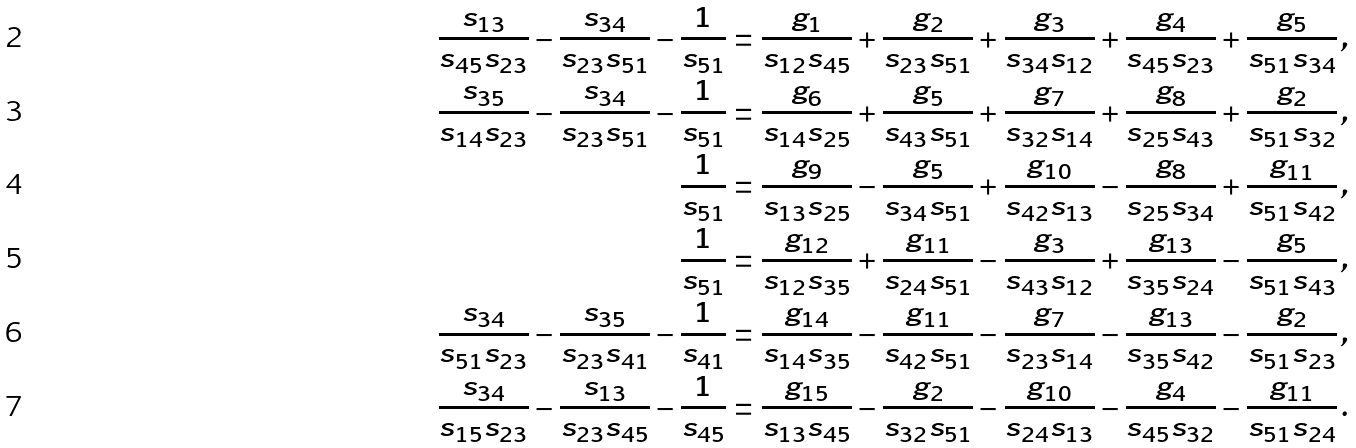<formula> <loc_0><loc_0><loc_500><loc_500>\frac { s _ { 1 3 } } { s _ { 4 5 } s _ { 2 3 } } - \frac { s _ { 3 4 } } { s _ { 2 3 } s _ { 5 1 } } - \frac { 1 } { s _ { 5 1 } } & = \frac { g _ { 1 } } { s _ { 1 2 } s _ { 4 5 } } + \frac { g _ { 2 } } { s _ { 2 3 } s _ { 5 1 } } + \frac { g _ { 3 } } { s _ { 3 4 } s _ { 1 2 } } + \frac { g _ { 4 } } { s _ { 4 5 } s _ { 2 3 } } + \frac { g _ { 5 } } { s _ { 5 1 } s _ { 3 4 } } \, , \\ \frac { s _ { 3 5 } } { s _ { 1 4 } s _ { 2 3 } } - \frac { s _ { 3 4 } } { s _ { 2 3 } s _ { 5 1 } } - \frac { 1 } { s _ { 5 1 } } & = \frac { g _ { 6 } } { s _ { 1 4 } s _ { 2 5 } } + \frac { g _ { 5 } } { s _ { 4 3 } s _ { 5 1 } } + \frac { g _ { 7 } } { s _ { 3 2 } s _ { 1 4 } } + \frac { g _ { 8 } } { s _ { 2 5 } s _ { 4 3 } } + \frac { g _ { 2 } } { s _ { 5 1 } s _ { 3 2 } } \, , \\ \frac { 1 } { s _ { 5 1 } } & = \frac { g _ { 9 } } { s _ { 1 3 } s _ { 2 5 } } - \frac { g _ { 5 } } { s _ { 3 4 } s _ { 5 1 } } + \frac { g _ { 1 0 } } { s _ { 4 2 } s _ { 1 3 } } - \frac { g _ { 8 } } { s _ { 2 5 } s _ { 3 4 } } + \frac { g _ { 1 1 } } { s _ { 5 1 } s _ { 4 2 } } \, , \\ \frac { 1 } { s _ { 5 1 } } & = \frac { g _ { 1 2 } } { s _ { 1 2 } s _ { 3 5 } } + \frac { g _ { 1 1 } } { s _ { 2 4 } s _ { 5 1 } } - \frac { g _ { 3 } } { s _ { 4 3 } s _ { 1 2 } } + \frac { g _ { 1 3 } } { s _ { 3 5 } s _ { 2 4 } } - \frac { g _ { 5 } } { s _ { 5 1 } s _ { 4 3 } } \, , \\ \frac { s _ { 3 4 } } { s _ { 5 1 } s _ { 2 3 } } - \frac { s _ { 3 5 } } { s _ { 2 3 } s _ { 4 1 } } - \frac { 1 } { s _ { 4 1 } } & = \frac { g _ { 1 4 } } { s _ { 1 4 } s _ { 3 5 } } - \frac { g _ { 1 1 } } { s _ { 4 2 } s _ { 5 1 } } - \frac { g _ { 7 } } { s _ { 2 3 } s _ { 1 4 } } - \frac { g _ { 1 3 } } { s _ { 3 5 } s _ { 4 2 } } - \frac { g _ { 2 } } { s _ { 5 1 } s _ { 2 3 } } \, , \\ \frac { s _ { 3 4 } } { s _ { 1 5 } s _ { 2 3 } } - \frac { s _ { 1 3 } } { s _ { 2 3 } s _ { 4 5 } } - \frac { 1 } { s _ { 4 5 } } & = \frac { g _ { 1 5 } } { s _ { 1 3 } s _ { 4 5 } } - \frac { g _ { 2 } } { s _ { 3 2 } s _ { 5 1 } } - \frac { g _ { 1 0 } } { s _ { 2 4 } s _ { 1 3 } } - \frac { g _ { 4 } } { s _ { 4 5 } s _ { 3 2 } } - \frac { g _ { 1 1 } } { s _ { 5 1 } s _ { 2 4 } } \, .</formula> 